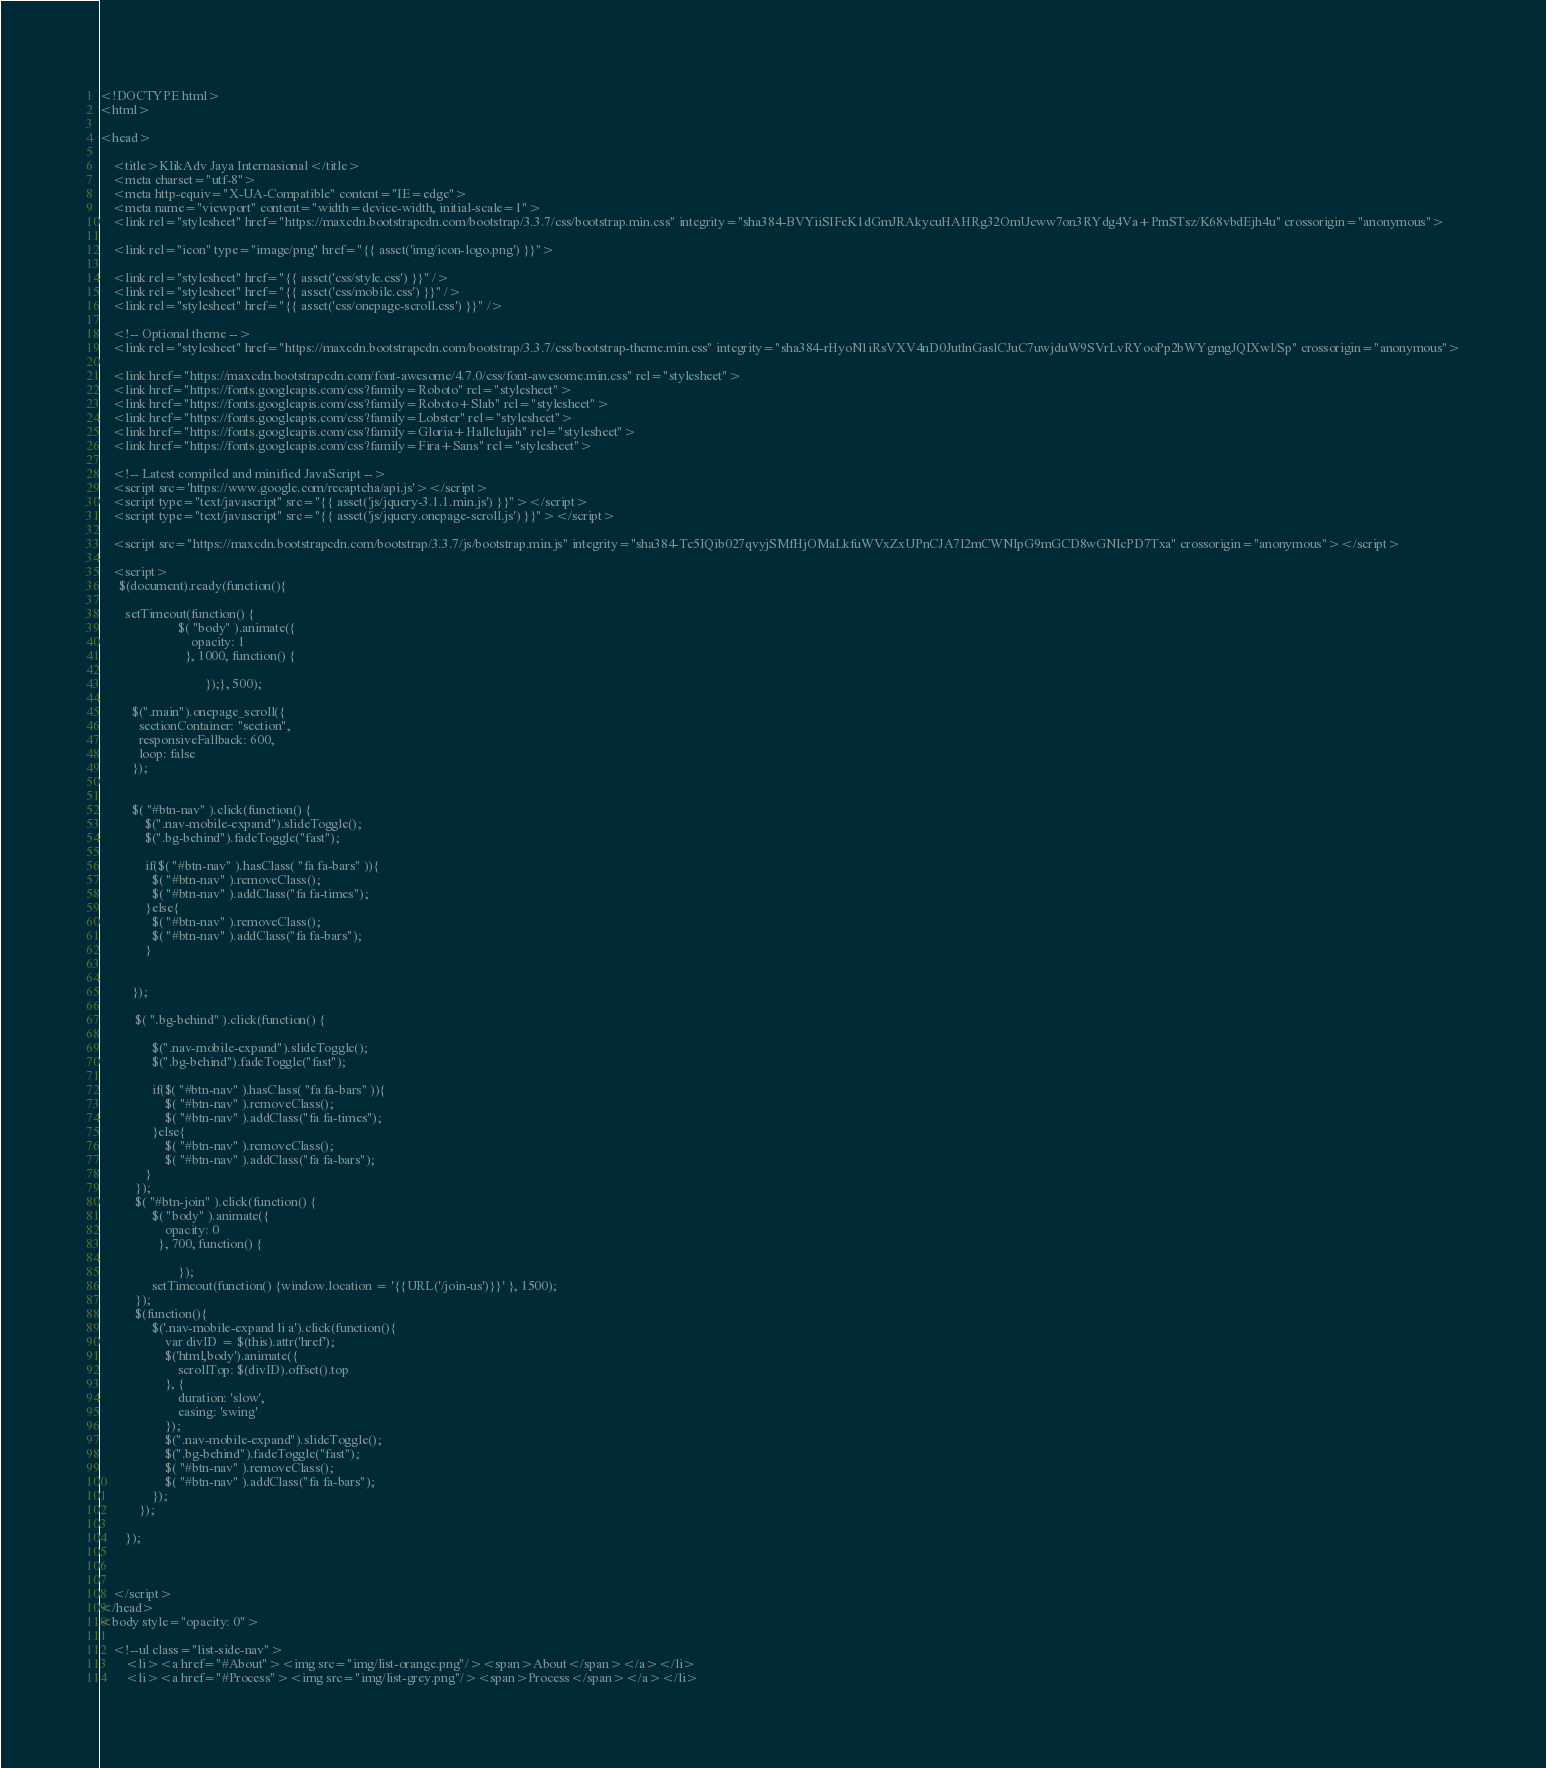Convert code to text. <code><loc_0><loc_0><loc_500><loc_500><_PHP_><!DOCTYPE html>
<html>

<head>

	<title>KlikAdv Jaya Internasional</title>
	<meta charset="utf-8">
    <meta http-equiv="X-UA-Compatible" content="IE=edge">
    <meta name="viewport" content="width=device-width, initial-scale=1">
	<link rel="stylesheet" href="https://maxcdn.bootstrapcdn.com/bootstrap/3.3.7/css/bootstrap.min.css" integrity="sha384-BVYiiSIFeK1dGmJRAkycuHAHRg32OmUcww7on3RYdg4Va+PmSTsz/K68vbdEjh4u" crossorigin="anonymous">

	<link rel="icon" type="image/png" href="{{ asset('img/icon-logo.png') }}">

	<link rel="stylesheet" href="{{ asset('css/style.css') }}" />
	<link rel="stylesheet" href="{{ asset('css/mobile.css') }}" />
	<link rel="stylesheet" href="{{ asset('css/onepage-scroll.css') }}" />

	<!-- Optional theme -->
	<link rel="stylesheet" href="https://maxcdn.bootstrapcdn.com/bootstrap/3.3.7/css/bootstrap-theme.min.css" integrity="sha384-rHyoN1iRsVXV4nD0JutlnGaslCJuC7uwjduW9SVrLvRYooPp2bWYgmgJQIXwl/Sp" crossorigin="anonymous">

	<link href="https://maxcdn.bootstrapcdn.com/font-awesome/4.7.0/css/font-awesome.min.css" rel="stylesheet">
	<link href="https://fonts.googleapis.com/css?family=Roboto" rel="stylesheet">
	<link href="https://fonts.googleapis.com/css?family=Roboto+Slab" rel="stylesheet">
	<link href="https://fonts.googleapis.com/css?family=Lobster" rel="stylesheet">
	<link href="https://fonts.googleapis.com/css?family=Gloria+Hallelujah" rel="stylesheet">
	<link href="https://fonts.googleapis.com/css?family=Fira+Sans" rel="stylesheet">

	<!-- Latest compiled and minified JavaScript -->
	<script src='https://www.google.com/recaptcha/api.js'></script>
	<script type="text/javascript" src="{{ asset('js/jquery-3.1.1.min.js') }}"></script>
	<script type="text/javascript" src="{{ asset('js/jquery.onepage-scroll.js') }}"></script>

	<script src="https://maxcdn.bootstrapcdn.com/bootstrap/3.3.7/js/bootstrap.min.js" integrity="sha384-Tc5IQib027qvyjSMfHjOMaLkfuWVxZxUPnCJA7l2mCWNIpG9mGCD8wGNIcPD7Txa" crossorigin="anonymous"></script>

	<script>
	  $(document).ready(function(){

	  	setTimeout(function() {
	     				$( "body" ).animate({
						    opacity: 1
						  }, 1000, function() {

		  						});}, 500);

	      $(".main").onepage_scroll({
	        sectionContainer: "section",
	        responsiveFallback: 600,
	        loop: false
	      });
	     

	      $( "#btn-nav" ).click(function() {
  			  $(".nav-mobile-expand").slideToggle();
  			  $(".bg-behind").fadeToggle("fast");

  			  if($( "#btn-nav" ).hasClass( "fa fa-bars" )){
  			  	$( "#btn-nav" ).removeClass();
  			  	$( "#btn-nav" ).addClass("fa fa-times");
  			  }else{
  			  	$( "#btn-nav" ).removeClass();
  			  	$( "#btn-nav" ).addClass("fa fa-bars");
  			  }

  			 
		  });

		   $( ".bg-behind" ).click(function() {

		   		$(".nav-mobile-expand").slideToggle();
		   		$(".bg-behind").fadeToggle("fast");

		   		if($( "#btn-nav" ).hasClass( "fa fa-bars" )){
  			  		$( "#btn-nav" ).removeClass();
  			  		$( "#btn-nav" ).addClass("fa fa-times");
  			  	}else{
  			  		$( "#btn-nav" ).removeClass();
  			  		$( "#btn-nav" ).addClass("fa fa-bars");
  			  }
		   });
		   $( "#btn-join" ).click(function() {
		   		$( "body" ).animate({
				    opacity: 0
				  }, 700, function() {

  						});
		   		setTimeout(function() {window.location = '{{URL('/join-us')}}' }, 1500);
		   });
		   $(function(){
			    $('.nav-mobile-expand li a').click(function(){
			        var divID = $(this).attr('href');
			        $('html,body').animate({
			            scrollTop: $(divID).offset().top 
			        }, {
			            duration: 'slow', 
			            easing: 'swing'
			        });
			        $(".nav-mobile-expand").slideToggle();
		   			$(".bg-behind").fadeToggle("fast");
		   			$( "#btn-nav" ).removeClass();
  			  		$( "#btn-nav" ).addClass("fa fa-bars");
			    }); 
			});

		});

		
	    
	</script>
</head>
<body style="opacity: 0">

	<!--ul class="list-side-nav">
		<li><a href="#About"><img src="img/list-orange.png"/><span>About</span></a></li>
		<li><a href="#Process"><img src="img/list-grey.png"/><span>Process</span></a></li></code> 